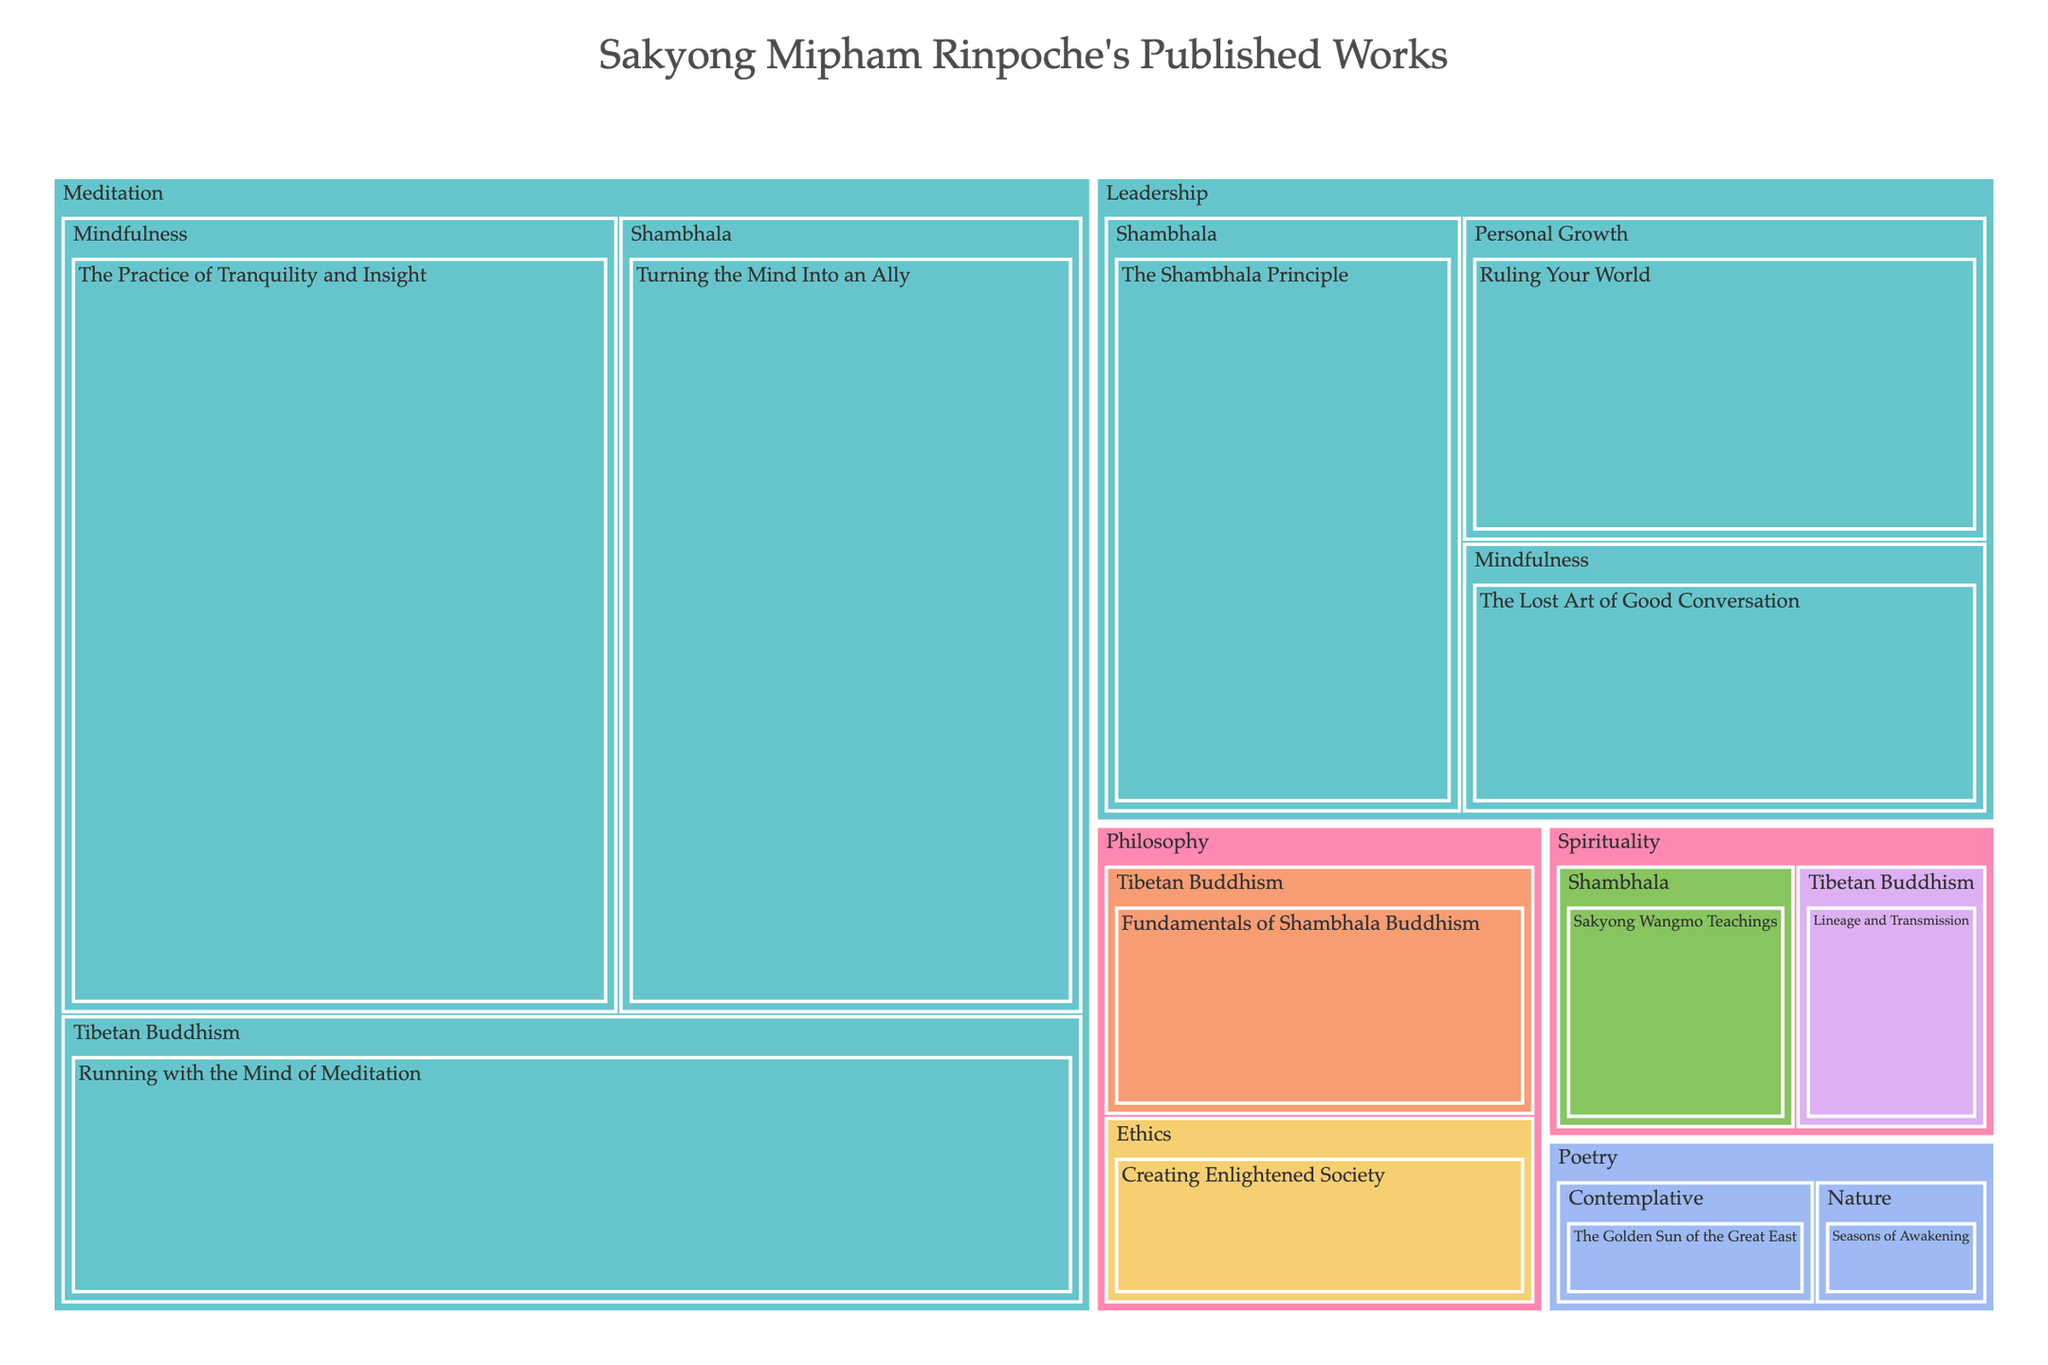What is the title of the treemap? The title of the treemap is located at the top of the visualization in a larger font size compared to the rest of the text. You can directly read it from there.
Answer: Sakyong Mipham Rinpoche's Published Works Which category has the largest total value in the treemap? To find the category with the largest total value, identify and sum up the values of its subcategories. "Meditation" has (30+25+20) = 75, "Leadership" has (15+10+12) = 37, "Philosophy" has (8+6) = 14, "Spirituality" has (5+4) = 9, and "Poetry" has (3+2) = 5. Meditation has the highest total value of 75.
Answer: Meditation What is the format with the highest total value in the "Leadership" category? Examine the subcategories within "Leadership" and look at the format for each title along with their values. The subcategories and their formats are: "The Shambhala Principle" (Book, 15), "The Lost Art of Good Conversation" (Book, 10), and "Ruling Your World" (Book, 12). The format is consistently "Book" with a total value of (15+10+12) = 37.
Answer: Book How does the value of "The Practice of Tranquility and Insight" compare to "Turning the Mind Into an Ally"? Locate both titles within the "Meditation" category and compare their values. "The Practice of Tranquility and Insight" has a value of 30, while "Turning the Mind Into an Ally" has a value of 25. 30 is greater than 25.
Answer: The Practice of Tranquility and Insight has a higher value Which subcategory in "Philosophy" has the highest value and what is its format? Compare the values of the subcategories within "Philosophy". "Fundamentals of Shambhala Buddhism" (Online Course, 8) and "Creating Enlightened Society" (Lecture Series, 6). The highest value is "Fundamentals of Shambhala Buddhism" with a value of 8 and the format is "Online Course".
Answer: Fundamentals of Shambhala Buddhism, Online Course What is the value of the smallest subcategory in the "Poetry" category? Identify and compare the values of the subcategories within "Poetry". "The Golden Sun of the Great East" has a value of 3, and "Seasons of Awakening" has a value of 2. The smallest subcategory value is 2.
Answer: 2 What is the color representation used for the format "Audio Recordings"? Locate any segment in the treemap where the format is "Audio Recordings". This format corresponds to the color used for "Sakyong Wangmo Teachings", identified by its portion in the treemap which uses a pastel color scheme specific to "Audio Recordings".
Answer: Pastel color (identify exact color visually) What is the total value of all works in the "Tibetan Buddhism" subcategory across all categories? Sum up the values of all titles under the subcategory "Tibetan Buddhism". The relevant works and their values are: "Running with the Mind of Meditation" (20) in "Meditation", and "Lineage and Transmission" (4) in "Spirituality". 20 + 4 = 24
Answer: 24 What is the average value of the published works in the "Spirituality" category? Add the values of all titles in "Spirituality" and divide by the number of titles. "Sakyong Wangmo Teachings" has a value of 5, and "Lineage and Transmission" has a value of 4. Their total is 5 + 4 = 9. As there are 2 titles, the average value is 9 / 2 = 4.5.
Answer: 4.5 